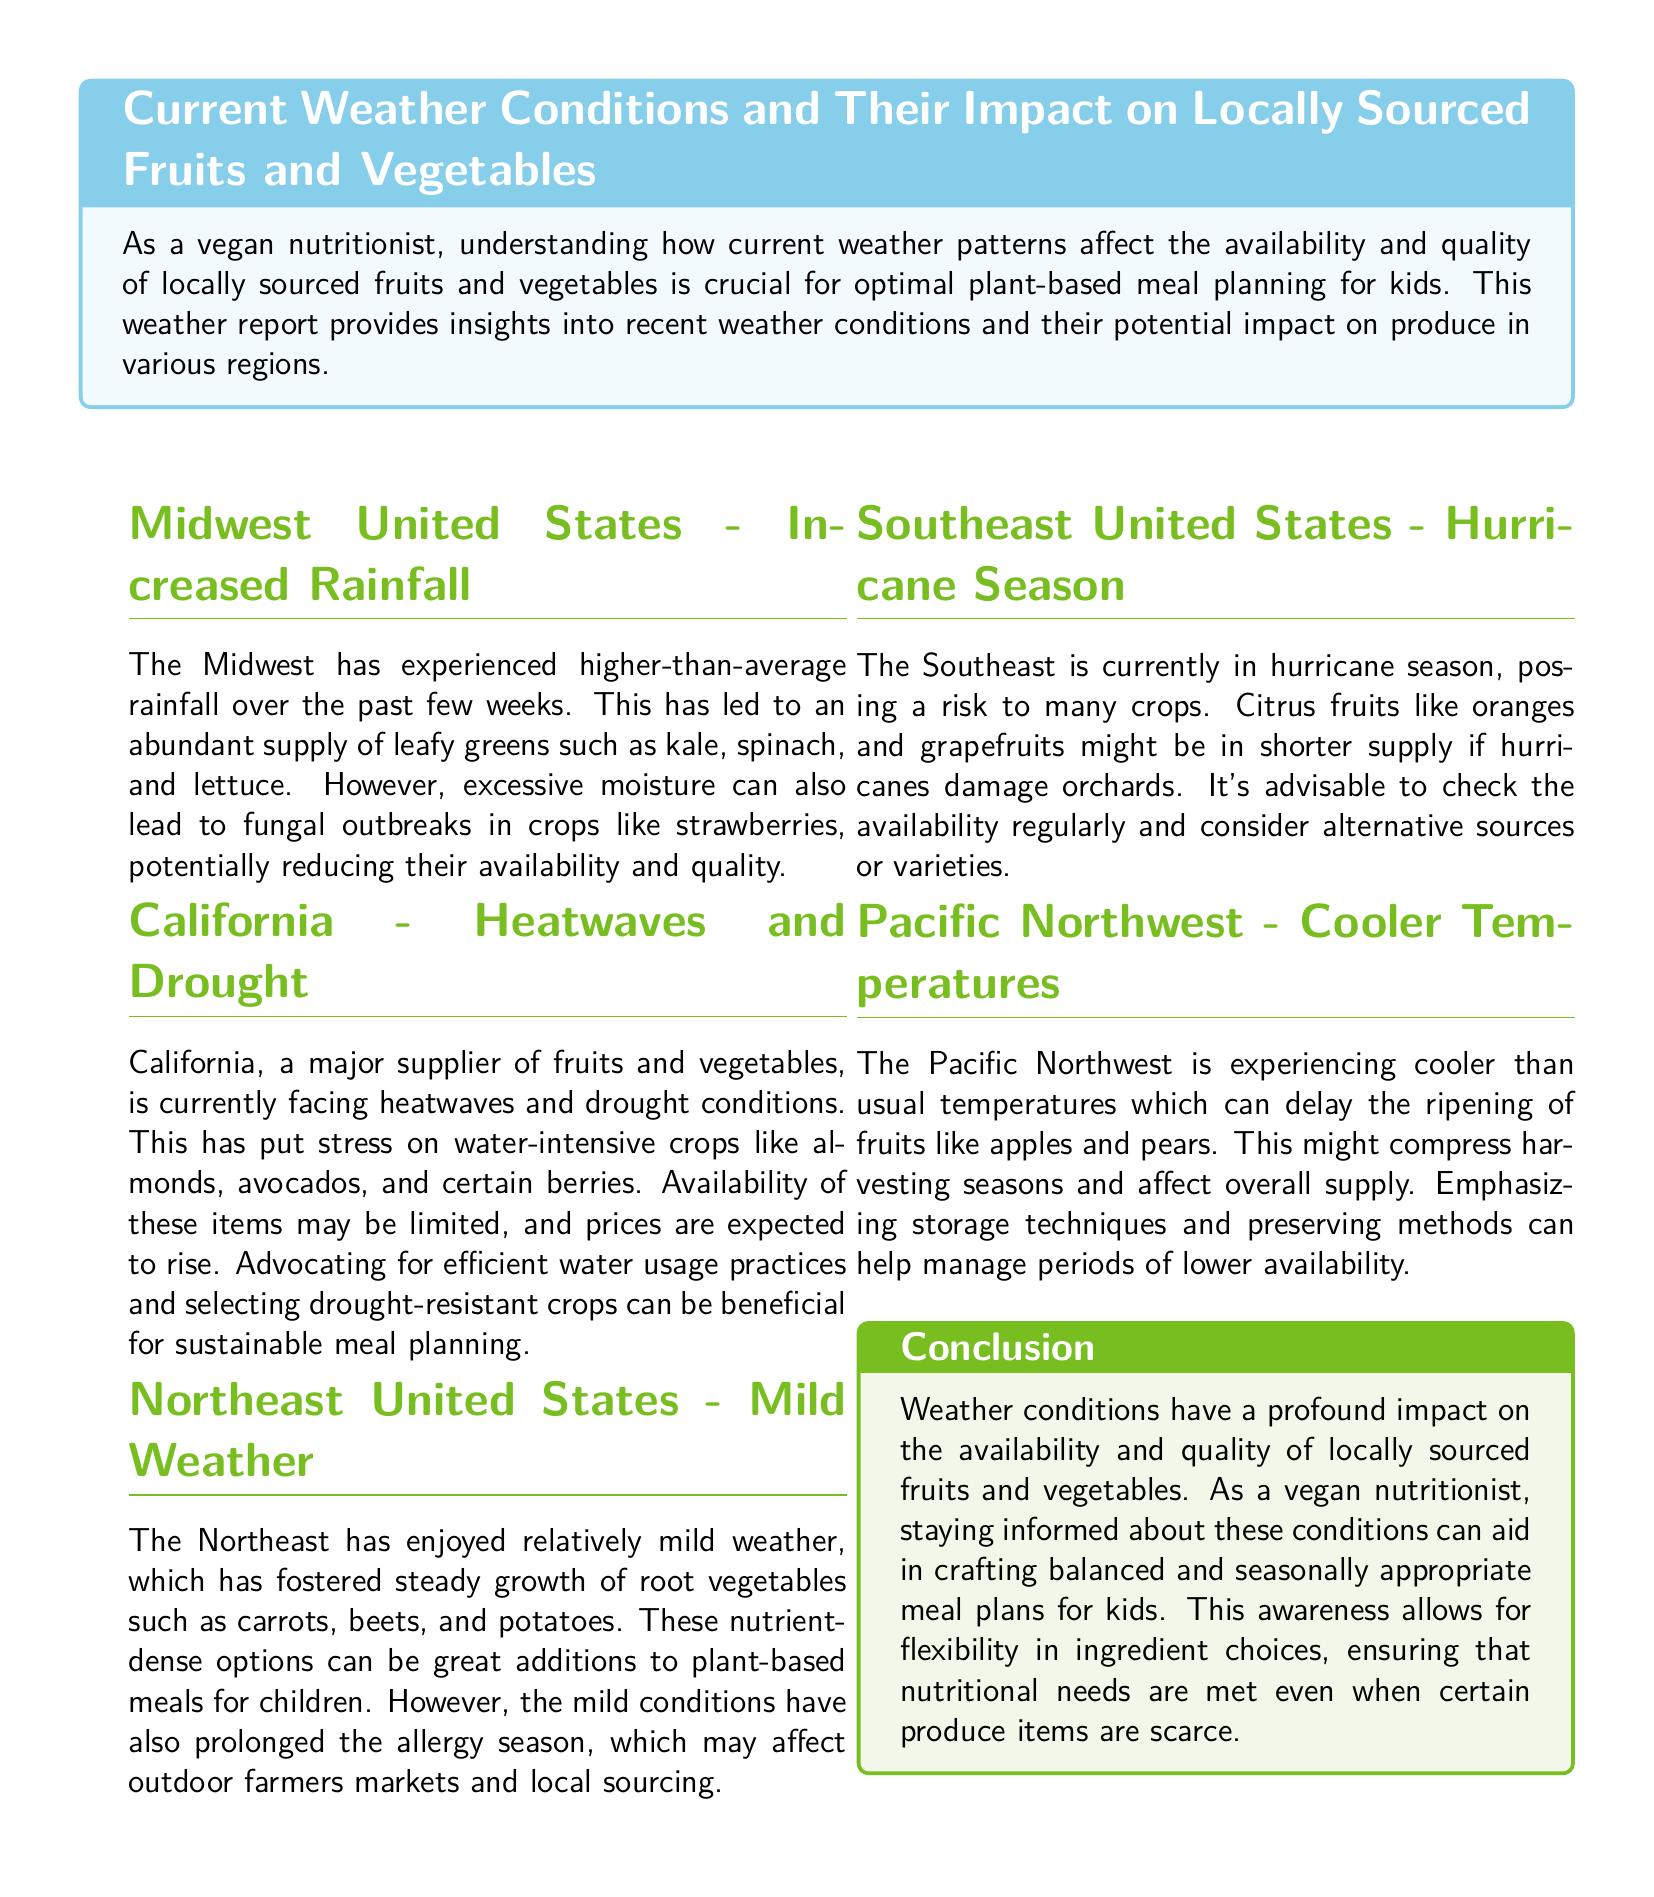What is the weather condition in the Midwest United States? The weather condition in the Midwest is characterized by increased rainfall, which has led to an abundant supply of leafy greens.
Answer: Increased Rainfall What crops are thriving in the Northeast United States? The document mentions that root vegetables such as carrots, beets, and potatoes are growing well in the Northeast due to mild weather.
Answer: Carrots, Beets, and Potatoes What risk is posed to crops in the Southeast United States? The document states that the Southeast is currently in hurricane season, which risks damaging crops.
Answer: Hurricane Season What effect does the heatwave have on California's crops? The heatwave and drought stress water-intensive crops, leading to limited availability and rising prices.
Answer: Limited availability and rising prices Which fruits might be in shorter supply in the Southeast? Citrus fruits like oranges and grapefruits are highlighted in the document as being in potentially shorter supply.
Answer: Oranges and Grapefruits What is a recommendation for California's crop sustainability? The document suggests advocating for efficient water usage practices and selecting drought-resistant crops.
Answer: Efficient water usage practices How does cooler weather affect the Pacific Northwest's fruit harvesting? Cooler temperatures are causing delays in the ripening and compressing harvesting seasons for fruits like apples and pears.
Answer: Delays in ripening What health concern is prolonged due to mild weather in the Northeast? The document indicates that mild conditions have prolonged the allergy season, impacting outdoor farmers markets.
Answer: Allergy season What is the main takeaway regarding weather impact on plant-based meal planning? The document concludes that awareness of weather conditions aids in crafting balanced and seasonally appropriate meal plans.
Answer: Aids in crafting balanced meal plans 